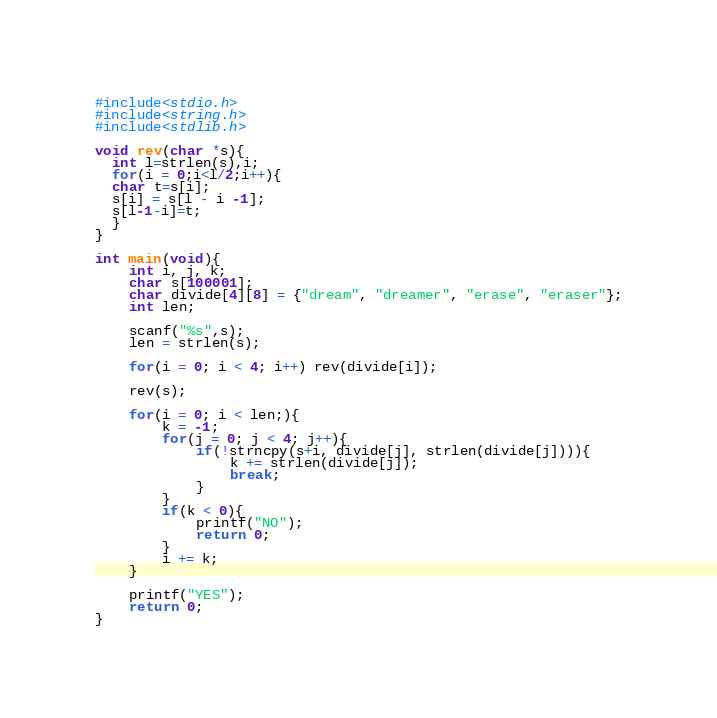<code> <loc_0><loc_0><loc_500><loc_500><_C_>#include<stdio.h>
#include<string.h>
#include<stdlib.h>

void rev(char *s){
  int l=strlen(s),i;
  for(i = 0;i<l/2;i++){
  char t=s[i];
  s[i] = s[l - i -1];
  s[l-1-i]=t;
  }
}

int main(void){
    int i, j, k;
    char s[100001];
    char divide[4][8] = {"dream", "dreamer", "erase", "eraser"};
    int len;
  
    scanf("%s",s);
    len = strlen(s);
    
    for(i = 0; i < 4; i++) rev(divide[i]);
  
    rev(s);
    
    for(i = 0; i < len;){
        k = -1;
        for(j = 0; j < 4; j++){
            if(!strncpy(s+i, divide[j], strlen(divide[j]))){
                k += strlen(divide[j]);
                break;
            }
        }  
        if(k < 0){
            printf("NO");
            return 0;
        }
        i += k;
    }
    
    printf("YES");
    return 0;
}
</code> 